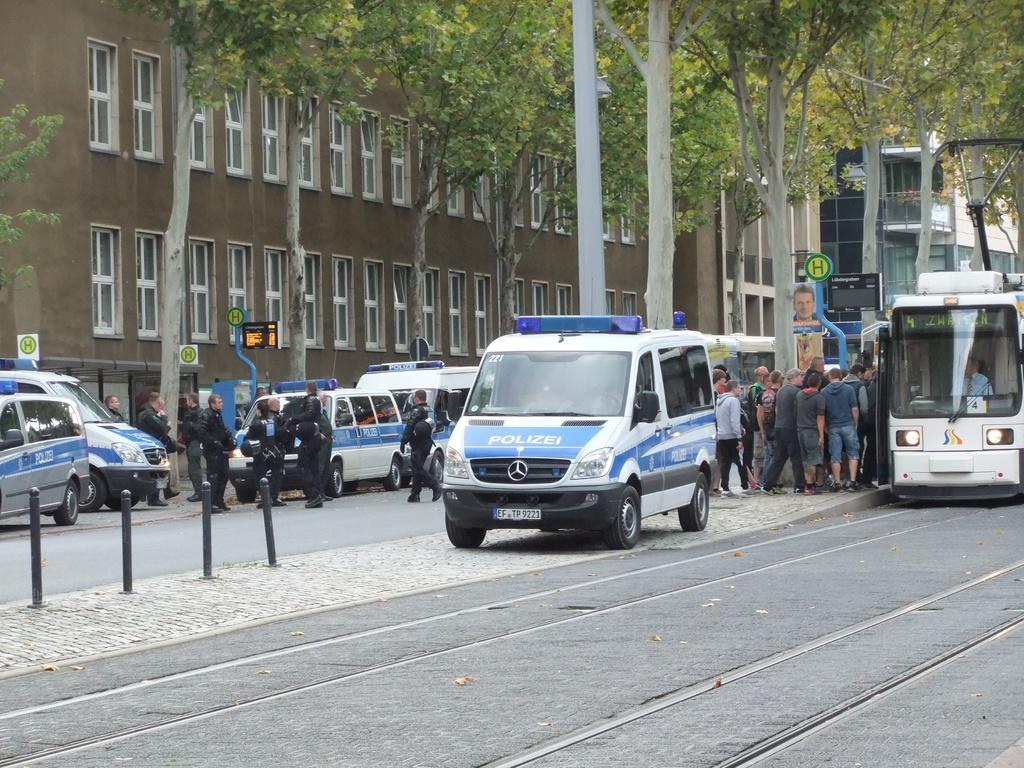<image>
Describe the image concisely. A parked blue and white Polizei vehicle on the street. 